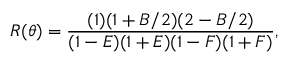<formula> <loc_0><loc_0><loc_500><loc_500>R ( \theta ) = \frac { ( 1 ) ( 1 + B / 2 ) ( 2 - B / 2 ) } { ( 1 - E ) ( 1 + E ) ( 1 - F ) ( 1 + F ) } ,</formula> 